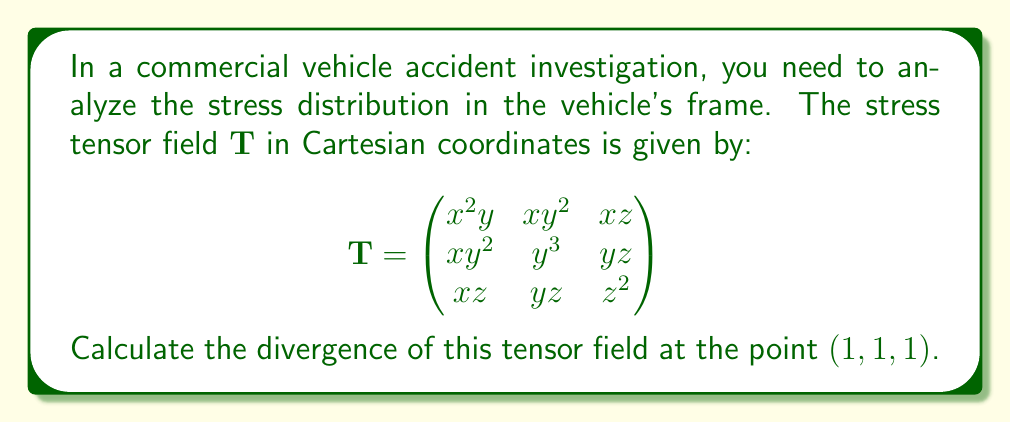Can you solve this math problem? To calculate the divergence of a tensor field, we need to follow these steps:

1) The divergence of a tensor field $\mathbf{T}$ is defined as:

   $$\nabla \cdot \mathbf{T} = \frac{\partial T_{xx}}{\partial x} + \frac{\partial T_{yy}}{\partial y} + \frac{\partial T_{zz}}{\partial z}$$

2) Let's calculate each partial derivative:

   $\frac{\partial T_{xx}}{\partial x} = \frac{\partial (x^2y)}{\partial x} = 2xy$

   $\frac{\partial T_{yy}}{\partial y} = \frac{\partial (y^3)}{\partial y} = 3y^2$

   $\frac{\partial T_{zz}}{\partial z} = \frac{\partial (z^2)}{\partial z} = 2z$

3) Now, we sum these partial derivatives:

   $$\nabla \cdot \mathbf{T} = 2xy + 3y^2 + 2z$$

4) To evaluate this at the point (1, 1, 1), we substitute x = 1, y = 1, and z = 1:

   $$\nabla \cdot \mathbf{T}|_{(1,1,1)} = 2(1)(1) + 3(1)^2 + 2(1) = 2 + 3 + 2 = 7$$

Therefore, the divergence of the tensor field at the point (1, 1, 1) is 7.
Answer: 7 